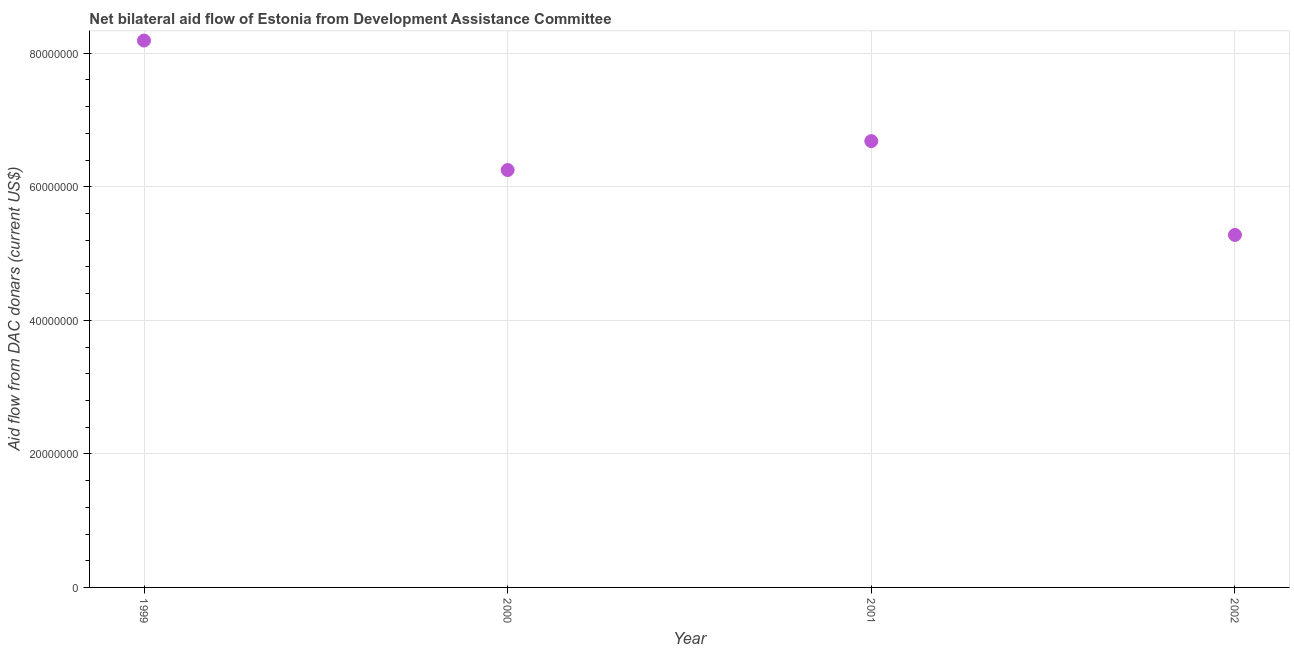What is the net bilateral aid flows from dac donors in 2000?
Ensure brevity in your answer.  6.25e+07. Across all years, what is the maximum net bilateral aid flows from dac donors?
Offer a terse response. 8.19e+07. Across all years, what is the minimum net bilateral aid flows from dac donors?
Your response must be concise. 5.28e+07. In which year was the net bilateral aid flows from dac donors maximum?
Your answer should be compact. 1999. In which year was the net bilateral aid flows from dac donors minimum?
Your answer should be very brief. 2002. What is the sum of the net bilateral aid flows from dac donors?
Provide a succinct answer. 2.64e+08. What is the difference between the net bilateral aid flows from dac donors in 1999 and 2000?
Provide a succinct answer. 1.94e+07. What is the average net bilateral aid flows from dac donors per year?
Give a very brief answer. 6.60e+07. What is the median net bilateral aid flows from dac donors?
Provide a succinct answer. 6.47e+07. Do a majority of the years between 2001 and 2002 (inclusive) have net bilateral aid flows from dac donors greater than 64000000 US$?
Your response must be concise. No. What is the ratio of the net bilateral aid flows from dac donors in 1999 to that in 2000?
Ensure brevity in your answer.  1.31. Is the difference between the net bilateral aid flows from dac donors in 2001 and 2002 greater than the difference between any two years?
Make the answer very short. No. What is the difference between the highest and the second highest net bilateral aid flows from dac donors?
Offer a terse response. 1.51e+07. Is the sum of the net bilateral aid flows from dac donors in 2001 and 2002 greater than the maximum net bilateral aid flows from dac donors across all years?
Keep it short and to the point. Yes. What is the difference between the highest and the lowest net bilateral aid flows from dac donors?
Your response must be concise. 2.91e+07. How many dotlines are there?
Give a very brief answer. 1. Does the graph contain any zero values?
Give a very brief answer. No. Does the graph contain grids?
Offer a very short reply. Yes. What is the title of the graph?
Keep it short and to the point. Net bilateral aid flow of Estonia from Development Assistance Committee. What is the label or title of the X-axis?
Offer a terse response. Year. What is the label or title of the Y-axis?
Keep it short and to the point. Aid flow from DAC donars (current US$). What is the Aid flow from DAC donars (current US$) in 1999?
Ensure brevity in your answer.  8.19e+07. What is the Aid flow from DAC donars (current US$) in 2000?
Make the answer very short. 6.25e+07. What is the Aid flow from DAC donars (current US$) in 2001?
Ensure brevity in your answer.  6.68e+07. What is the Aid flow from DAC donars (current US$) in 2002?
Provide a succinct answer. 5.28e+07. What is the difference between the Aid flow from DAC donars (current US$) in 1999 and 2000?
Ensure brevity in your answer.  1.94e+07. What is the difference between the Aid flow from DAC donars (current US$) in 1999 and 2001?
Make the answer very short. 1.51e+07. What is the difference between the Aid flow from DAC donars (current US$) in 1999 and 2002?
Provide a short and direct response. 2.91e+07. What is the difference between the Aid flow from DAC donars (current US$) in 2000 and 2001?
Your answer should be compact. -4.33e+06. What is the difference between the Aid flow from DAC donars (current US$) in 2000 and 2002?
Your answer should be compact. 9.72e+06. What is the difference between the Aid flow from DAC donars (current US$) in 2001 and 2002?
Make the answer very short. 1.40e+07. What is the ratio of the Aid flow from DAC donars (current US$) in 1999 to that in 2000?
Make the answer very short. 1.31. What is the ratio of the Aid flow from DAC donars (current US$) in 1999 to that in 2001?
Give a very brief answer. 1.23. What is the ratio of the Aid flow from DAC donars (current US$) in 1999 to that in 2002?
Make the answer very short. 1.55. What is the ratio of the Aid flow from DAC donars (current US$) in 2000 to that in 2001?
Offer a very short reply. 0.94. What is the ratio of the Aid flow from DAC donars (current US$) in 2000 to that in 2002?
Make the answer very short. 1.18. What is the ratio of the Aid flow from DAC donars (current US$) in 2001 to that in 2002?
Keep it short and to the point. 1.27. 